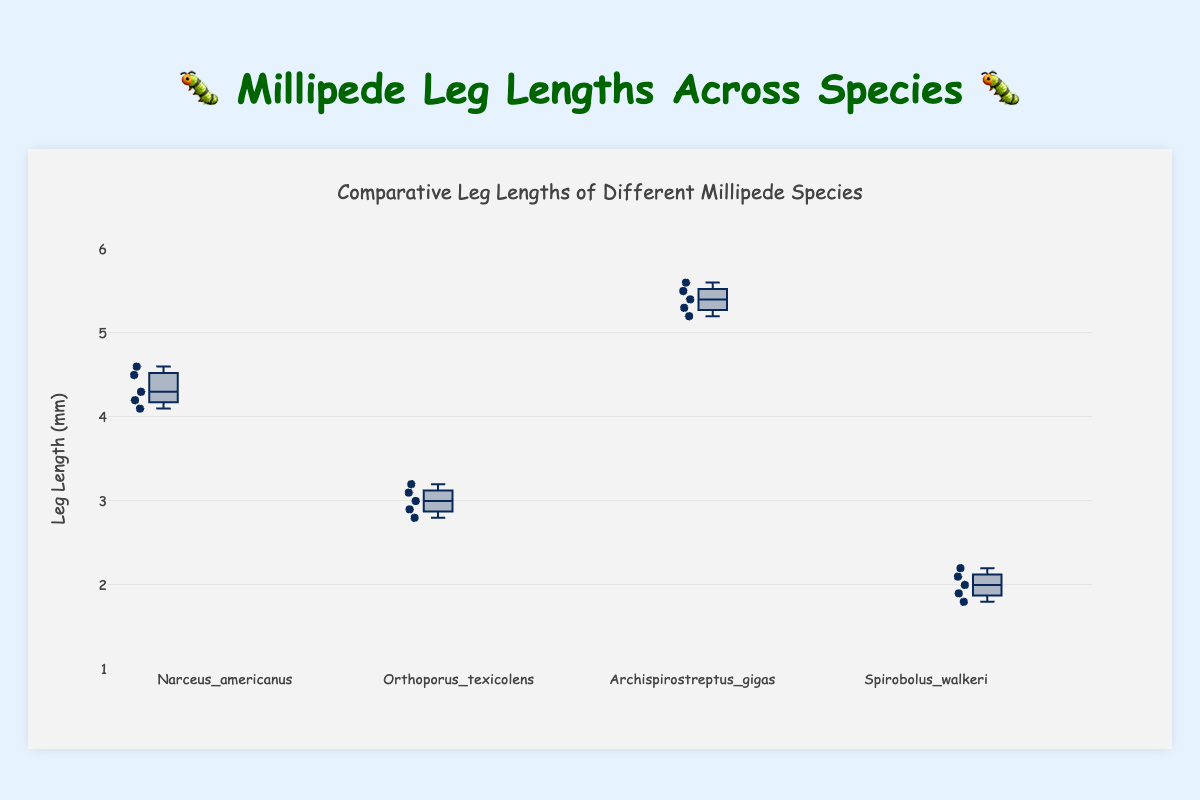What's the title of the chart? The title of the chart is usually placed at the top of the figure. In this case, the title is "Comparative Leg Lengths of Different Millipede Species", as seen at the top center of the figure.
Answer: Comparative Leg Lengths of Different Millipede Species Which species has the longest median leg length? To find the species with the longest median leg length, compare the central lines in each box plot. "Archispirostreptus_gigas" has the highest central line, indicating the longest median leg length.
Answer: Archispirostreptus_gigas Which species has the shortest leg length overall? Look at the minimum whisker values for each species in the box plot. "Spirobolus_walkeri" has the lowest minimum value, indicating the shortest leg length overall.
Answer: Spirobolus_walkeri How many data points are there for "Orthoporus_texicolens"? The data points are shown as dots overlaying the box plot. Count the data points for "Orthoporus_texicolens" – there are 5 points.
Answer: 5 What is the range of leg lengths for "Narceus_americanus"? Find the difference between the maximum and minimum values represented by the whiskers for "Narceus_americanus." The range is 4.6 - 4.1 = 0.5 mm.
Answer: 0.5 mm Which species has the most consistent leg length measurements? Consistency is indicated by the smallest interquartile range (IQR), which is the length of the box. "Orthoporus_texicolens" has the smallest box, indicating the most consistent measurements.
Answer: Orthoporus_texicolens How does the median leg length of "Archispirostreptus_gigas" compare to "Orthoporus_texicolens"? Compare the central lines of "Archispirostreptus_gigas" and "Orthoporus_texicolens". The median of "Archispirostreptus_gigas", about 5.4 mm, is greater than "Orthoporus_texicolens", which is about 3.0 mm.
Answer: Archispirostreptus_gigas is greater What are the interquartile ranges (IQR) for "Spirobolus_walkeri" and "Narceus_americanus"? The IQR is the difference between the third quartile (upper edge of the box) and the first quartile (lower edge of the box). For "Spirobolus_walkeri", it is 2.2 - 1.9 = 0.3 mm. For "Narceus_americanus", it is 4.5 - 4.2 = 0.3 mm.
Answer: Both 0.3 mm What are the upper and lower whiskers for "Archispirostreptus_gigas"? The whiskers represent the minimum and maximum values excluding outliers. For "Archispirostreptus_gigas", the lower whisker is at 5.2 mm and the upper whisker is at 5.6 mm.
Answer: Lower: 5.2 mm, Upper: 5.6 mm 